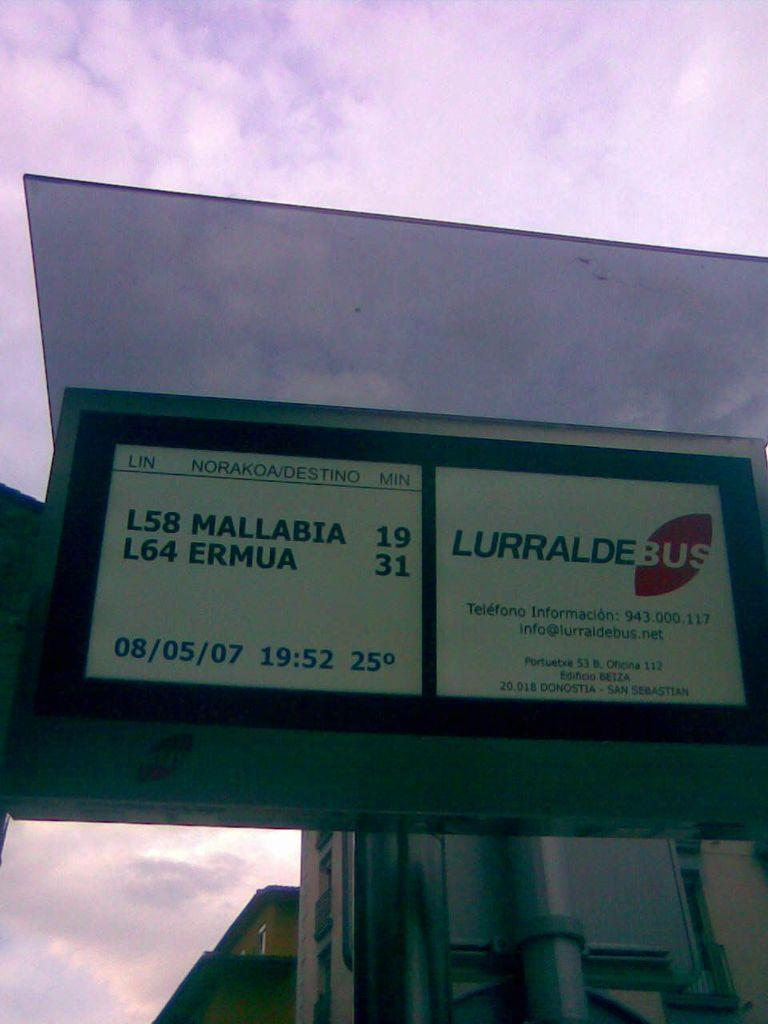<image>
Write a terse but informative summary of the picture. a sign for the Lurralde Bus and other information 